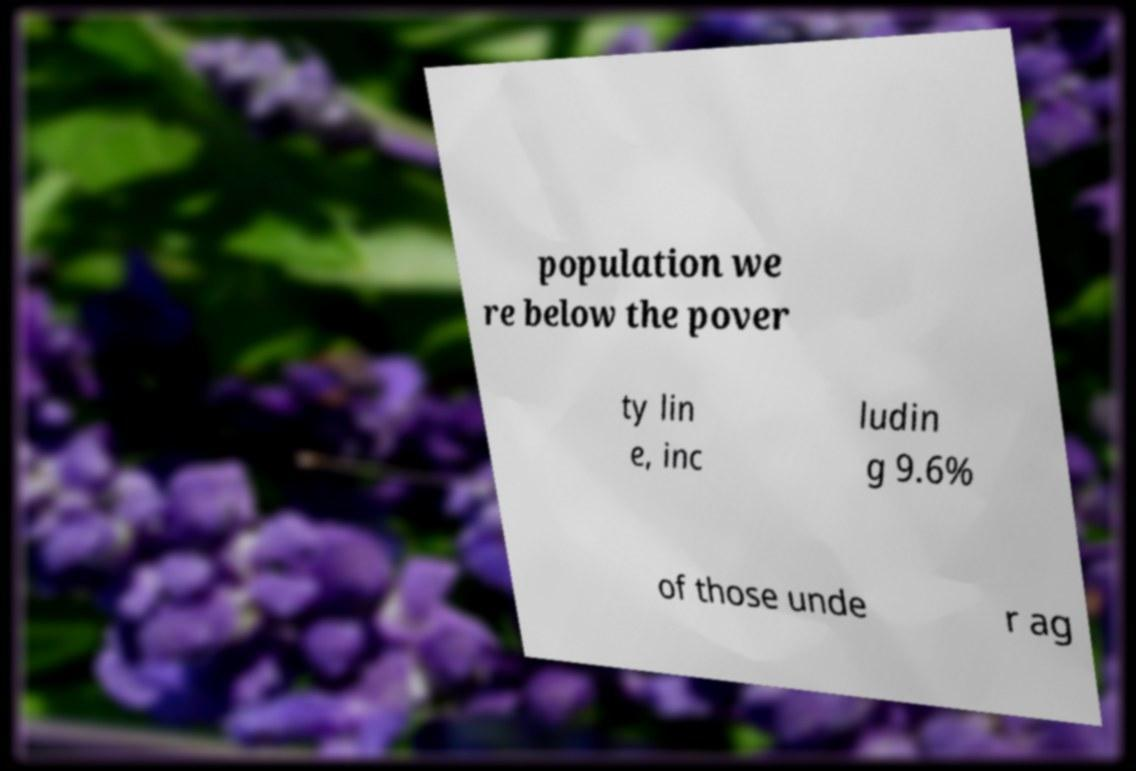For documentation purposes, I need the text within this image transcribed. Could you provide that? population we re below the pover ty lin e, inc ludin g 9.6% of those unde r ag 